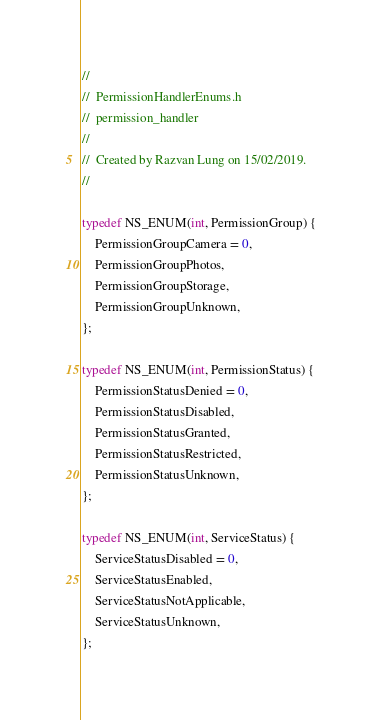<code> <loc_0><loc_0><loc_500><loc_500><_C_>//
//  PermissionHandlerEnums.h
//  permission_handler
//
//  Created by Razvan Lung on 15/02/2019.
//

typedef NS_ENUM(int, PermissionGroup) {
    PermissionGroupCamera = 0,
    PermissionGroupPhotos,
    PermissionGroupStorage,
    PermissionGroupUnknown,
};

typedef NS_ENUM(int, PermissionStatus) {
    PermissionStatusDenied = 0,
    PermissionStatusDisabled,
    PermissionStatusGranted,
    PermissionStatusRestricted,
    PermissionStatusUnknown,
};

typedef NS_ENUM(int, ServiceStatus) {
    ServiceStatusDisabled = 0,
    ServiceStatusEnabled,
    ServiceStatusNotApplicable,
    ServiceStatusUnknown,
};
</code> 